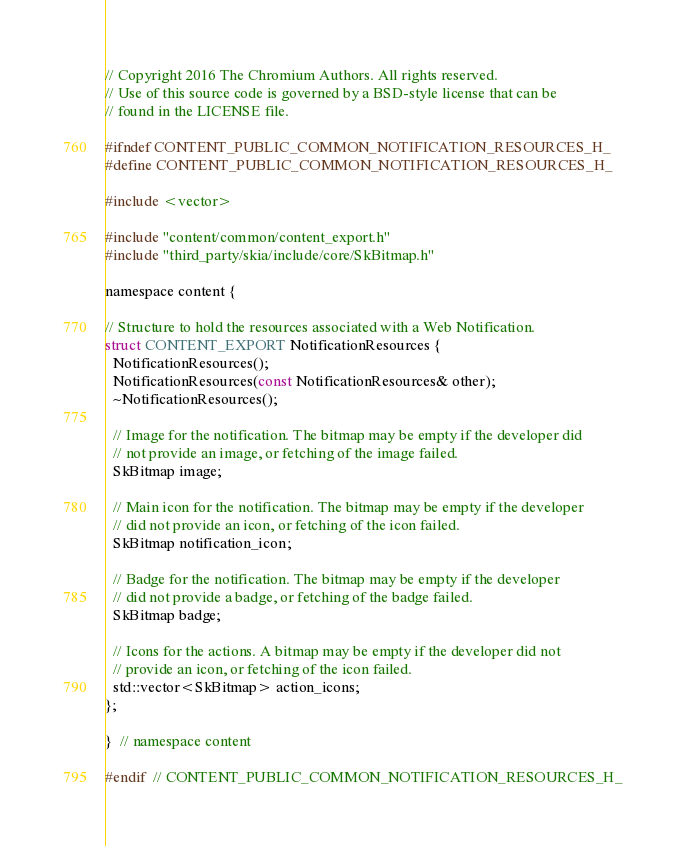Convert code to text. <code><loc_0><loc_0><loc_500><loc_500><_C_>// Copyright 2016 The Chromium Authors. All rights reserved.
// Use of this source code is governed by a BSD-style license that can be
// found in the LICENSE file.

#ifndef CONTENT_PUBLIC_COMMON_NOTIFICATION_RESOURCES_H_
#define CONTENT_PUBLIC_COMMON_NOTIFICATION_RESOURCES_H_

#include <vector>

#include "content/common/content_export.h"
#include "third_party/skia/include/core/SkBitmap.h"

namespace content {

// Structure to hold the resources associated with a Web Notification.
struct CONTENT_EXPORT NotificationResources {
  NotificationResources();
  NotificationResources(const NotificationResources& other);
  ~NotificationResources();

  // Image for the notification. The bitmap may be empty if the developer did
  // not provide an image, or fetching of the image failed.
  SkBitmap image;

  // Main icon for the notification. The bitmap may be empty if the developer
  // did not provide an icon, or fetching of the icon failed.
  SkBitmap notification_icon;

  // Badge for the notification. The bitmap may be empty if the developer
  // did not provide a badge, or fetching of the badge failed.
  SkBitmap badge;

  // Icons for the actions. A bitmap may be empty if the developer did not
  // provide an icon, or fetching of the icon failed.
  std::vector<SkBitmap> action_icons;
};

}  // namespace content

#endif  // CONTENT_PUBLIC_COMMON_NOTIFICATION_RESOURCES_H_
</code> 